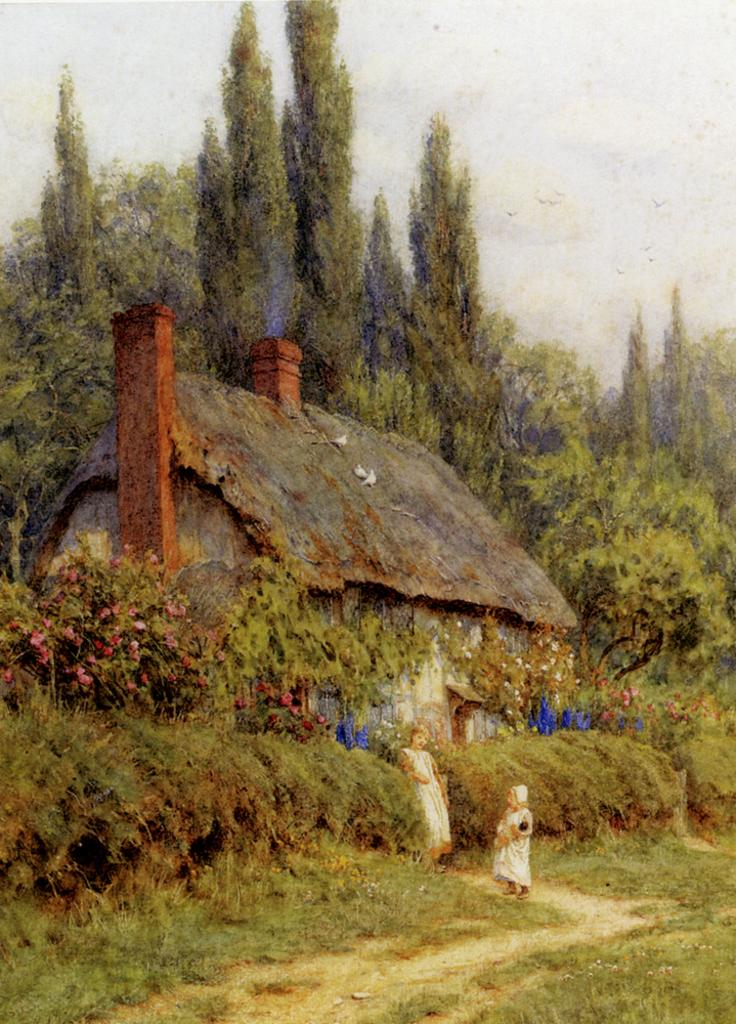What type of structure is visible in the image? There is a hut in the image. What type of vegetation can be seen in the image? There are flowers, plants, and grass visible in the image. What else can be seen in the image besides the hut and vegetation? There are other objects in the image. What type of cable is used to connect the hut to the power source in the image? There is no cable or power source visible in the image, and therefore no such connection can be observed. 